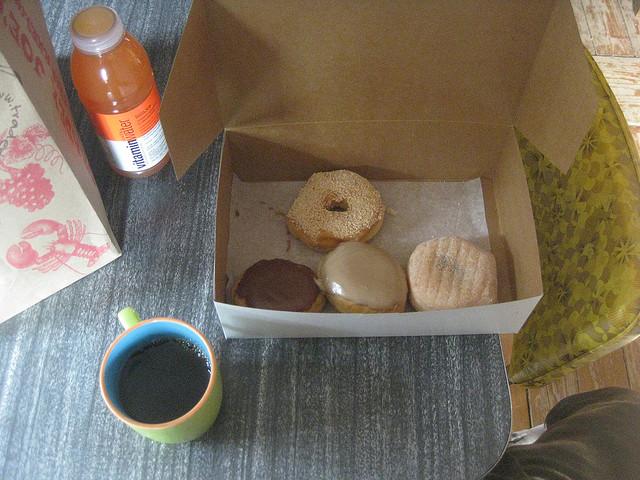What color is the box?
Write a very short answer. White. What type of water is on the left?
Concise answer only. Vitamin water. How many donuts are left?
Quick response, please. 4. 